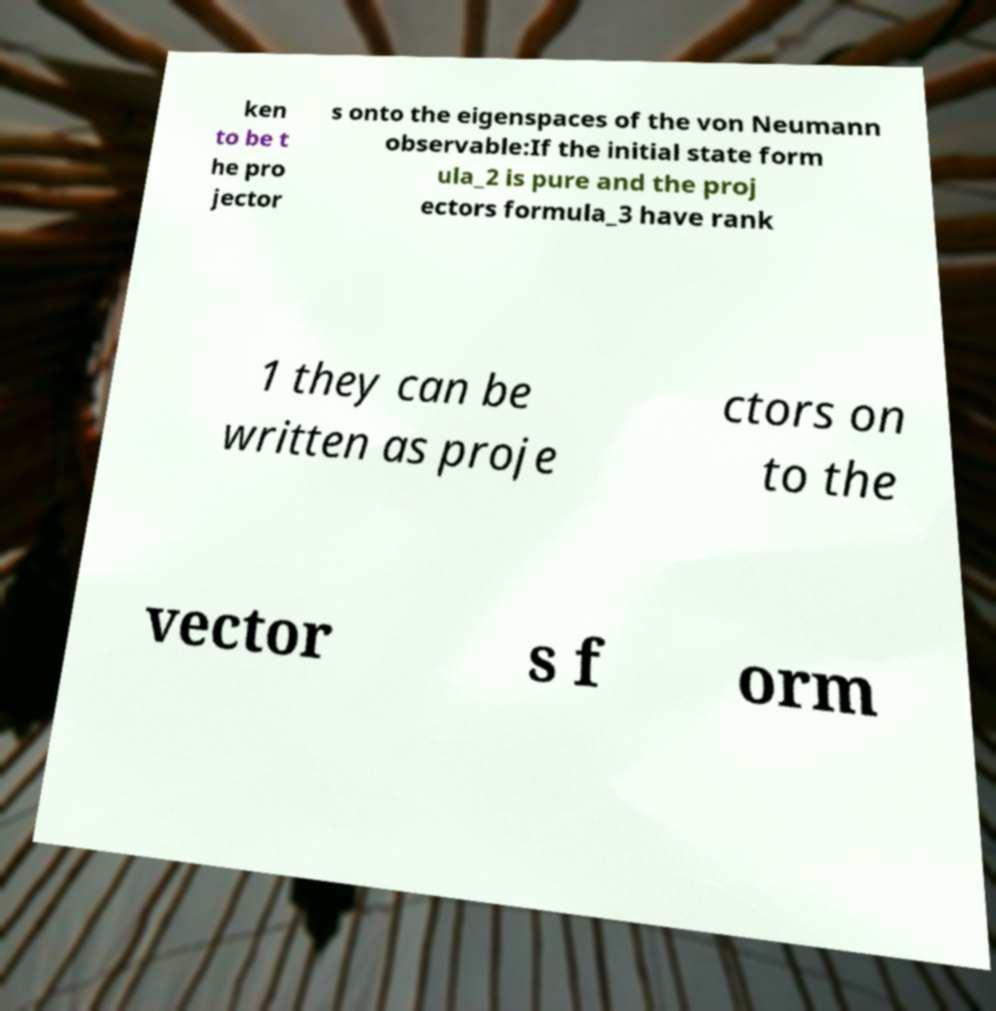Please identify and transcribe the text found in this image. ken to be t he pro jector s onto the eigenspaces of the von Neumann observable:If the initial state form ula_2 is pure and the proj ectors formula_3 have rank 1 they can be written as proje ctors on to the vector s f orm 